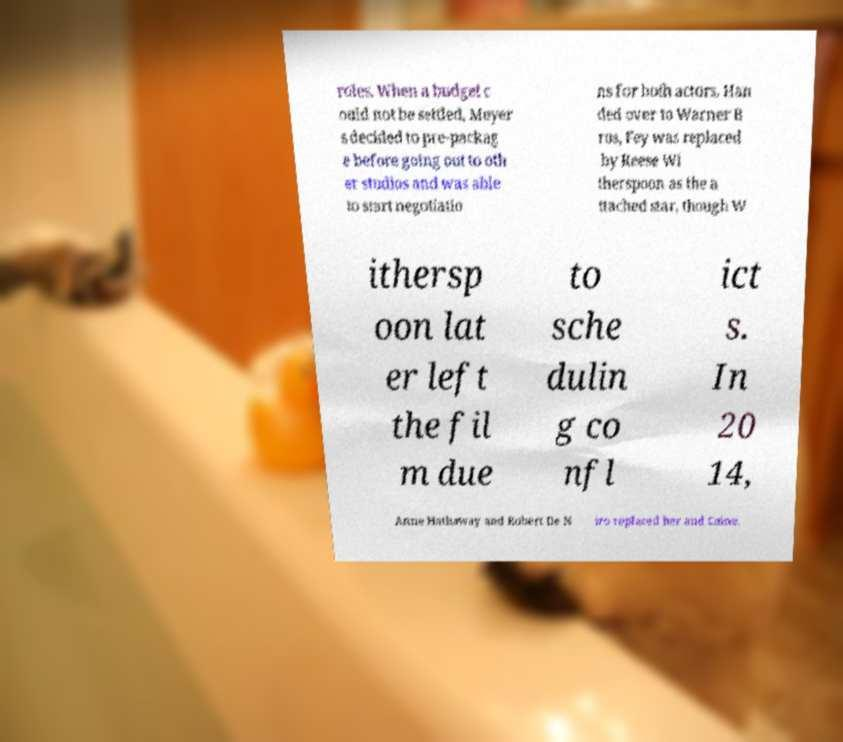Could you extract and type out the text from this image? roles. When a budget c ould not be settled, Meyer s decided to pre-packag e before going out to oth er studios and was able to start negotiatio ns for both actors. Han ded over to Warner B ros, Fey was replaced by Reese Wi therspoon as the a ttached star, though W ithersp oon lat er left the fil m due to sche dulin g co nfl ict s. In 20 14, Anne Hathaway and Robert De N iro replaced her and Caine. 